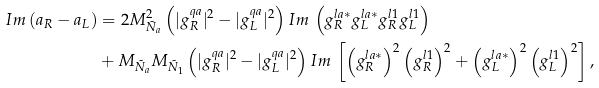<formula> <loc_0><loc_0><loc_500><loc_500>I m \, ( a _ { R } - a _ { L } ) & = 2 M _ { \tilde { N } _ { a } } ^ { 2 } \left ( | g ^ { q a } _ { R } | ^ { 2 } - | g ^ { q a } _ { L } | ^ { 2 } \right ) I m \, \left ( g ^ { l a * } _ { R } g ^ { l a * } _ { L } g ^ { l 1 } _ { R } g ^ { l 1 } _ { L } \right ) \\ & + M _ { \tilde { N } _ { a } } M _ { \tilde { N } _ { 1 } } \left ( | g ^ { q a } _ { R } | ^ { 2 } - | g ^ { q a } _ { L } | ^ { 2 } \right ) I m \, \left [ \left ( g ^ { l a * } _ { R } \right ) ^ { 2 } \left ( g _ { R } ^ { l 1 } \right ) ^ { 2 } + \left ( g ^ { l a * } _ { L } \right ) ^ { 2 } \left ( g _ { L } ^ { l 1 } \right ) ^ { 2 } \right ] ,</formula> 